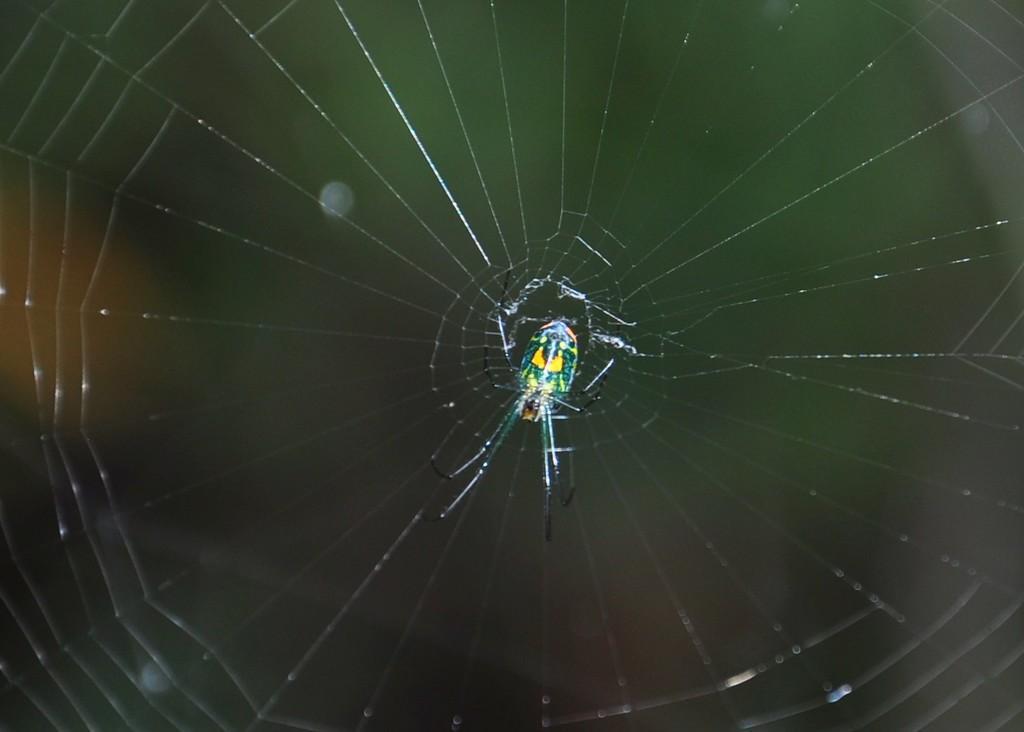Please provide a concise description of this image. In this image, we can see a spider and spider web, there is a blur background. 